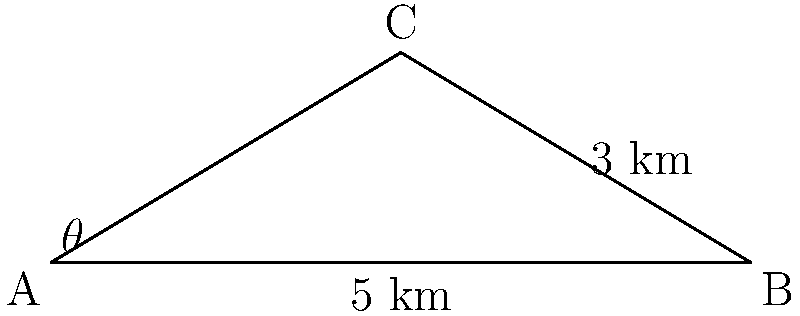A conservationist is studying the flight path of migratory birds between two feeding grounds. The birds typically fly from point A to point C, stopping at point B along the way. If the distance between A and B is 5 km, and the height of point C above the AB line is 3 km, what is the optimal angle $\theta$ for the birds to fly directly from A to C to minimize energy expenditure? To find the optimal angle for the bird's flight path, we need to use trigonometry. Let's approach this step-by-step:

1) We have a right triangle ABC, where:
   - AB is the base (5 km)
   - BC is the height (3 km)
   - AC is the hypotenuse (the direct flight path)

2) We need to find the angle $\theta$ at point A.

3) In a right triangle, $\tan(\theta)$ is equal to the opposite side divided by the adjacent side:

   $$\tan(\theta) = \frac{\text{opposite}}{\text{adjacent}} = \frac{BC}{AB} = \frac{3}{5}$$

4) To find $\theta$, we need to take the inverse tangent (arctan or $\tan^{-1}$) of this ratio:

   $$\theta = \tan^{-1}\left(\frac{3}{5}\right)$$

5) Using a calculator or trigonometric tables:

   $$\theta \approx 30.96^\circ$$

6) Round to the nearest degree:

   $$\theta \approx 31^\circ$$

This angle represents the optimal path for the birds to fly directly from A to C, minimizing the distance traveled and thus energy expenditure.
Answer: $31^\circ$ 